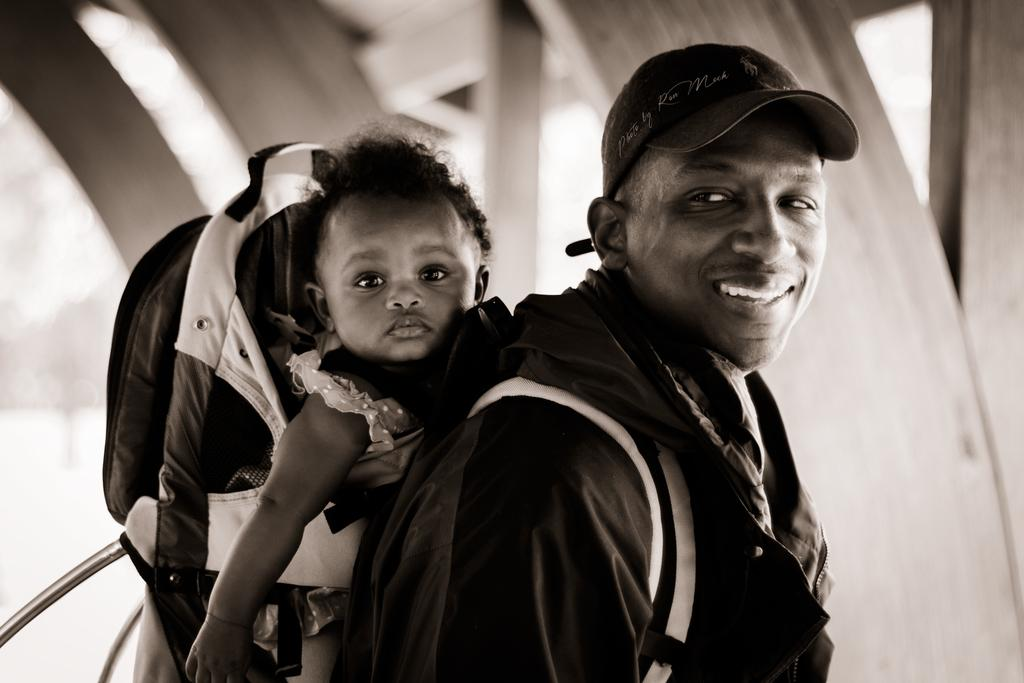What is the main subject of the image? There is a person in the image. What is the person wearing on their head? The person is wearing a hat. What type of clothing is the person wearing on their upper body? The person is wearing a jacket. What accessory is the person carrying? The person is wearing a bag. What is the facial expression of the person in the image? The person is smiling. Can you describe the contents of the bag? There is a child in the bag. What can be seen in the background of the image? There are blurry objects in the background of the image. What beginner system is being used by the person in the image? There is no mention of a beginner system in the image or the provided facts. 